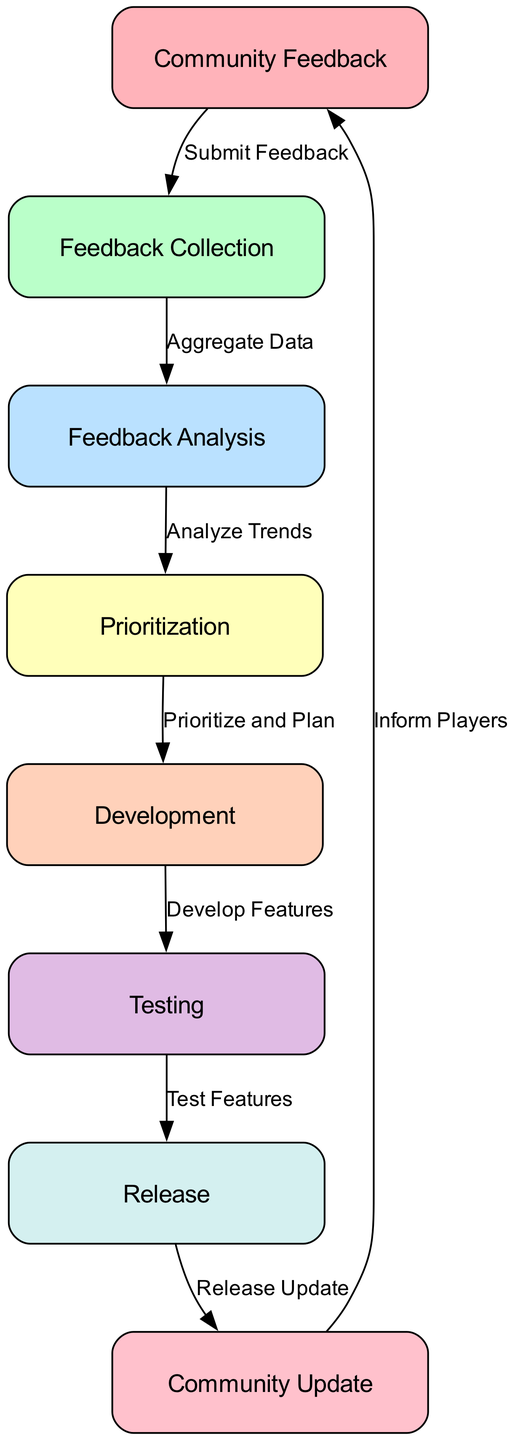What is the first node in the diagram? The first node in the flow is "Community Feedback." It is where players submit their suggestions and feedback. This can be deduced by looking at the top of the diagram's flow, which starts with this node.
Answer: Community Feedback How many nodes are present in the diagram? By counting the listed elements, there are eight distinct nodes in the diagram. Each node represents a specific stage in the community feedback process.
Answer: Eight What is the label of the node that directly follows "Feedback Collection"? The node that follows "Feedback Collection" is "Feedback Analysis." This is determined by tracing the flow from "Feedback Collection" down to its connected node.
Answer: Feedback Analysis Which node has the label "Testing"? The node labeled "Testing" is found after "Development." By following the flow in the diagram, "Development" connects directly to "Testing."
Answer: Testing What is the last step before the community update? The last step before the community update is "Release." This is identified by observing the flow that ends at the "Community Update" node, which follows the "Release" node.
Answer: Release How many connections are there between nodes in the diagram? There are seven connections shown in the diagram, indicating the flow from one node to another. This can be confirmed by counting the connections listed in the "connections" section of the data.
Answer: Seven What phase follows the "Prioritization" phase? The phase that follows "Prioritization" is "Development." This is inferred by following the arrows in the diagram that direct from "Prioritization" to "Development."
Answer: Development Which node represents the analysis of feedback? The node that represents the analysis of feedback is "Feedback Analysis." It directly relates to evaluating the feedback collected from the community.
Answer: Feedback Analysis What does the "Release" node communicate to the players? The "Release" node communicates the deployment of updates or features along with patch notes. It indicates what changes have been implemented based on community feedback.
Answer: Deployment of new updates or features 